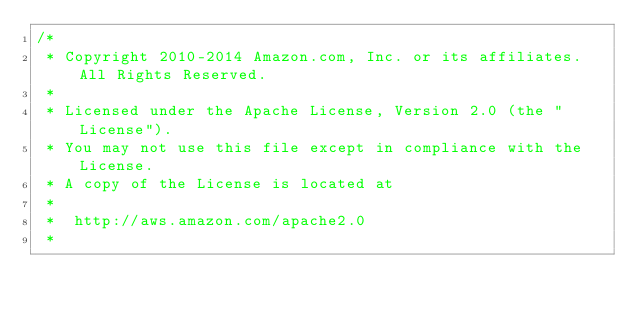<code> <loc_0><loc_0><loc_500><loc_500><_C#_>/*
 * Copyright 2010-2014 Amazon.com, Inc. or its affiliates. All Rights Reserved.
 * 
 * Licensed under the Apache License, Version 2.0 (the "License").
 * You may not use this file except in compliance with the License.
 * A copy of the License is located at
 * 
 *  http://aws.amazon.com/apache2.0
 * </code> 